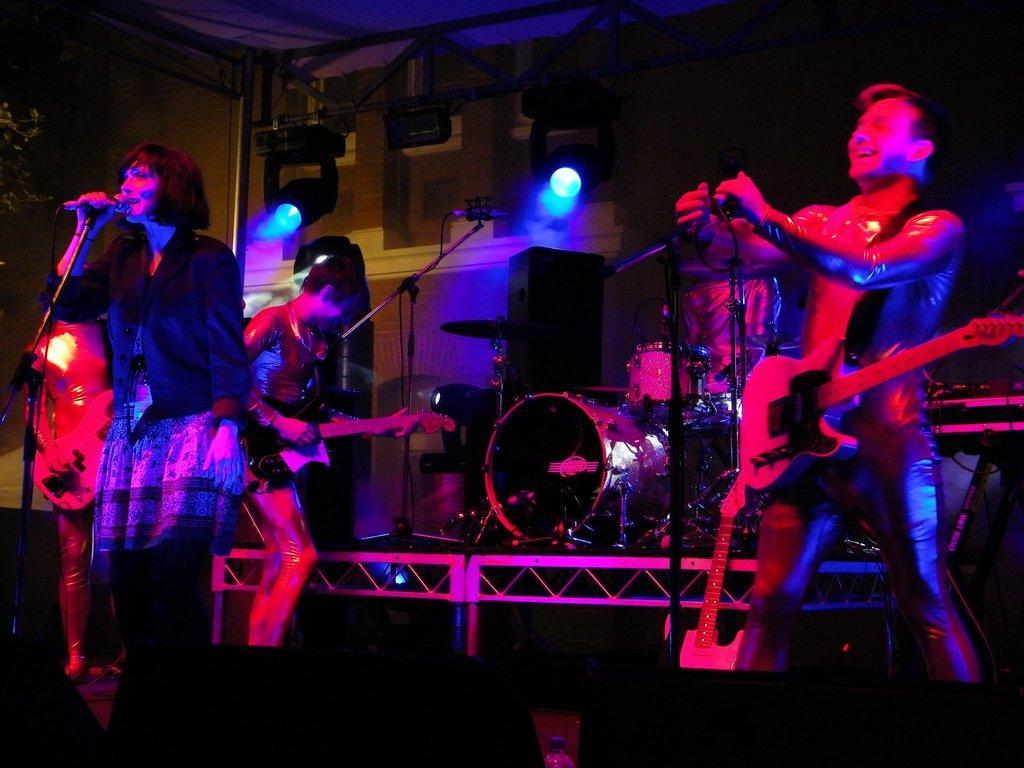Describe this image in one or two sentences. In this picture I can see people holding musical instruments. I can see a woman holding microphone. I can see DJ lights. 